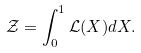<formula> <loc_0><loc_0><loc_500><loc_500>\mathcal { Z } = \int _ { 0 } ^ { 1 } { \mathcal { L } ( X ) } d X .</formula> 